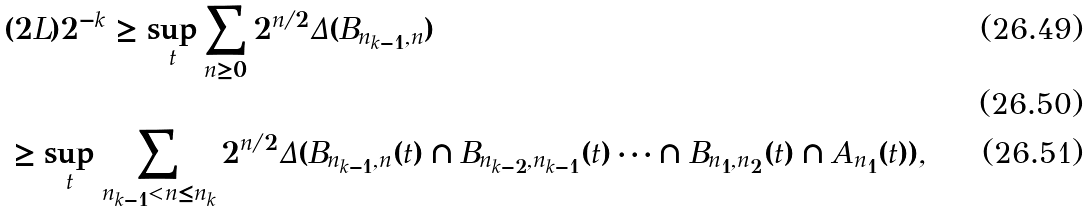<formula> <loc_0><loc_0><loc_500><loc_500>& ( 2 L ) 2 ^ { - k } \geq \sup _ { t } \sum _ { n \geq 0 } 2 ^ { n / 2 } \Delta ( B _ { n _ { k - 1 } , n } ) \\ & \\ & \geq \sup _ { t } \sum _ { n _ { k - 1 } < n \leq n _ { k } } 2 ^ { n / 2 } \Delta ( B _ { n _ { k - 1 } , n } ( t ) \cap B _ { n _ { k - 2 } , n _ { k - 1 } } ( t ) \cdots \cap B _ { n _ { 1 } , n _ { 2 } } ( t ) \cap A _ { n _ { 1 } } ( t ) ) ,</formula> 